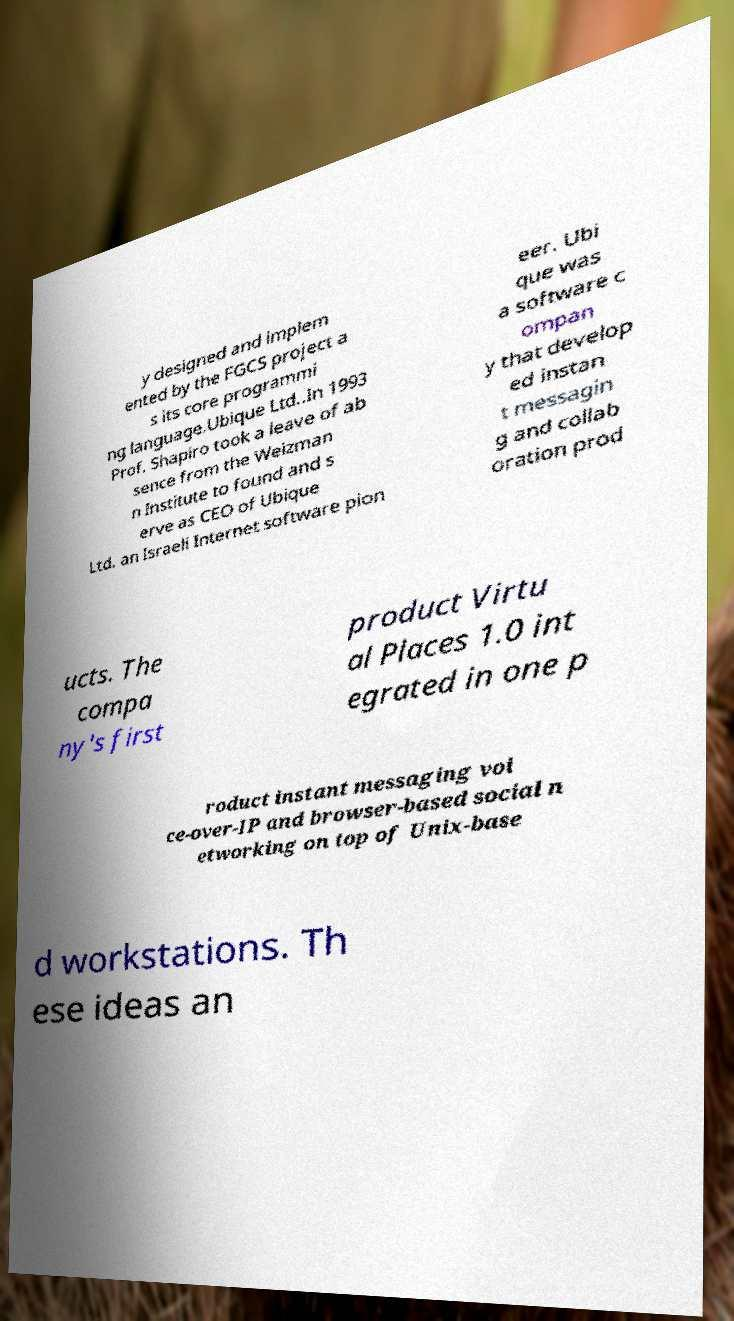Can you accurately transcribe the text from the provided image for me? y designed and implem ented by the FGCS project a s its core programmi ng language.Ubique Ltd..In 1993 Prof. Shapiro took a leave of ab sence from the Weizman n Institute to found and s erve as CEO of Ubique Ltd. an Israeli Internet software pion eer. Ubi que was a software c ompan y that develop ed instan t messagin g and collab oration prod ucts. The compa ny's first product Virtu al Places 1.0 int egrated in one p roduct instant messaging voi ce-over-IP and browser-based social n etworking on top of Unix-base d workstations. Th ese ideas an 